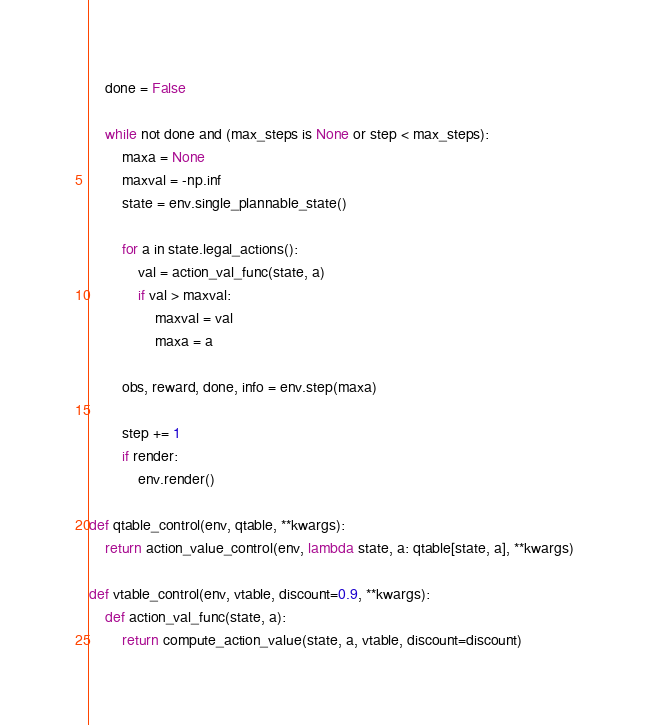<code> <loc_0><loc_0><loc_500><loc_500><_Python_>    done = False

    while not done and (max_steps is None or step < max_steps):
        maxa = None
        maxval = -np.inf
        state = env.single_plannable_state()

        for a in state.legal_actions():
            val = action_val_func(state, a)
            if val > maxval:
                maxval = val
                maxa = a

        obs, reward, done, info = env.step(maxa)

        step += 1
        if render:
            env.render()

def qtable_control(env, qtable, **kwargs):
    return action_value_control(env, lambda state, a: qtable[state, a], **kwargs)

def vtable_control(env, vtable, discount=0.9, **kwargs):
    def action_val_func(state, a):
        return compute_action_value(state, a, vtable, discount=discount)</code> 